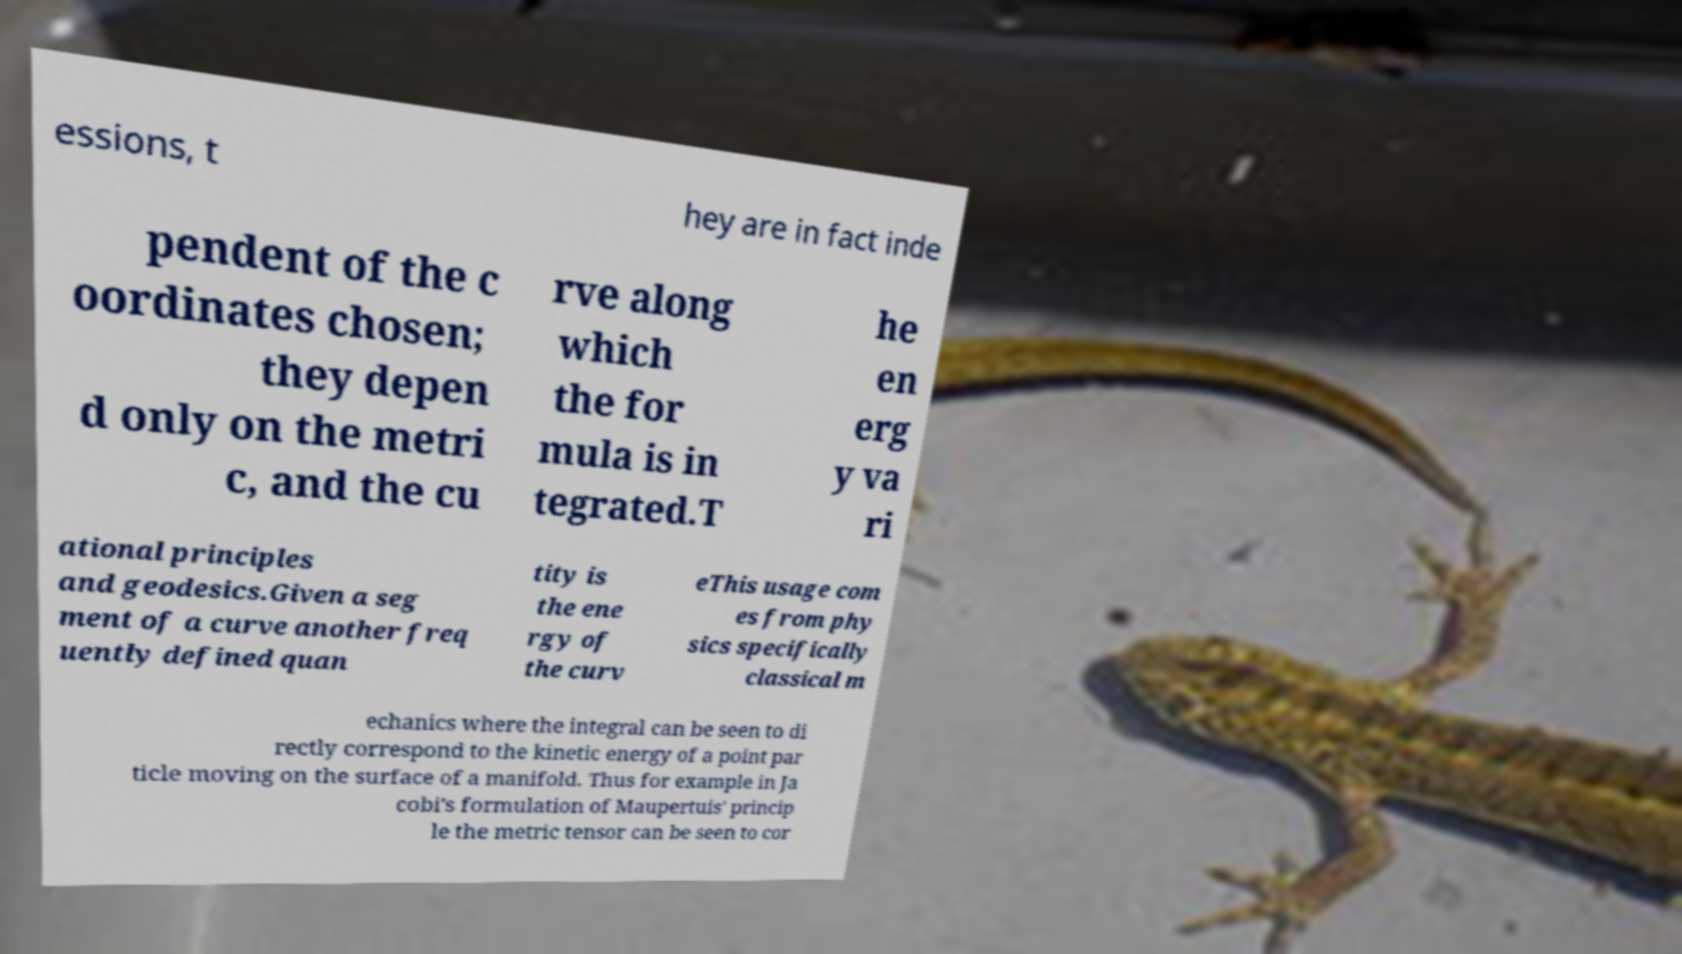For documentation purposes, I need the text within this image transcribed. Could you provide that? essions, t hey are in fact inde pendent of the c oordinates chosen; they depen d only on the metri c, and the cu rve along which the for mula is in tegrated.T he en erg y va ri ational principles and geodesics.Given a seg ment of a curve another freq uently defined quan tity is the ene rgy of the curv eThis usage com es from phy sics specifically classical m echanics where the integral can be seen to di rectly correspond to the kinetic energy of a point par ticle moving on the surface of a manifold. Thus for example in Ja cobi's formulation of Maupertuis' princip le the metric tensor can be seen to cor 